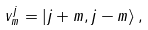Convert formula to latex. <formula><loc_0><loc_0><loc_500><loc_500>v ^ { j } _ { m } = | j + m , j - m \rangle \, ,</formula> 